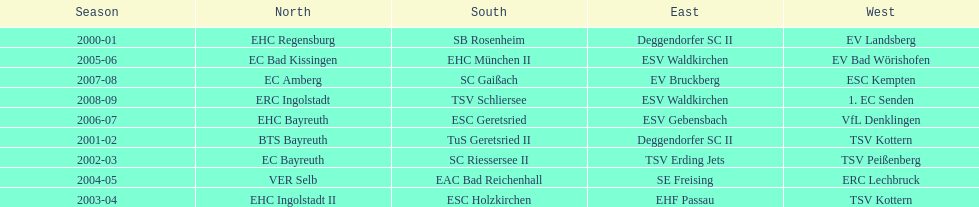Who won the south after esc geretsried did during the 2006-07 season? SC Gaißach. 